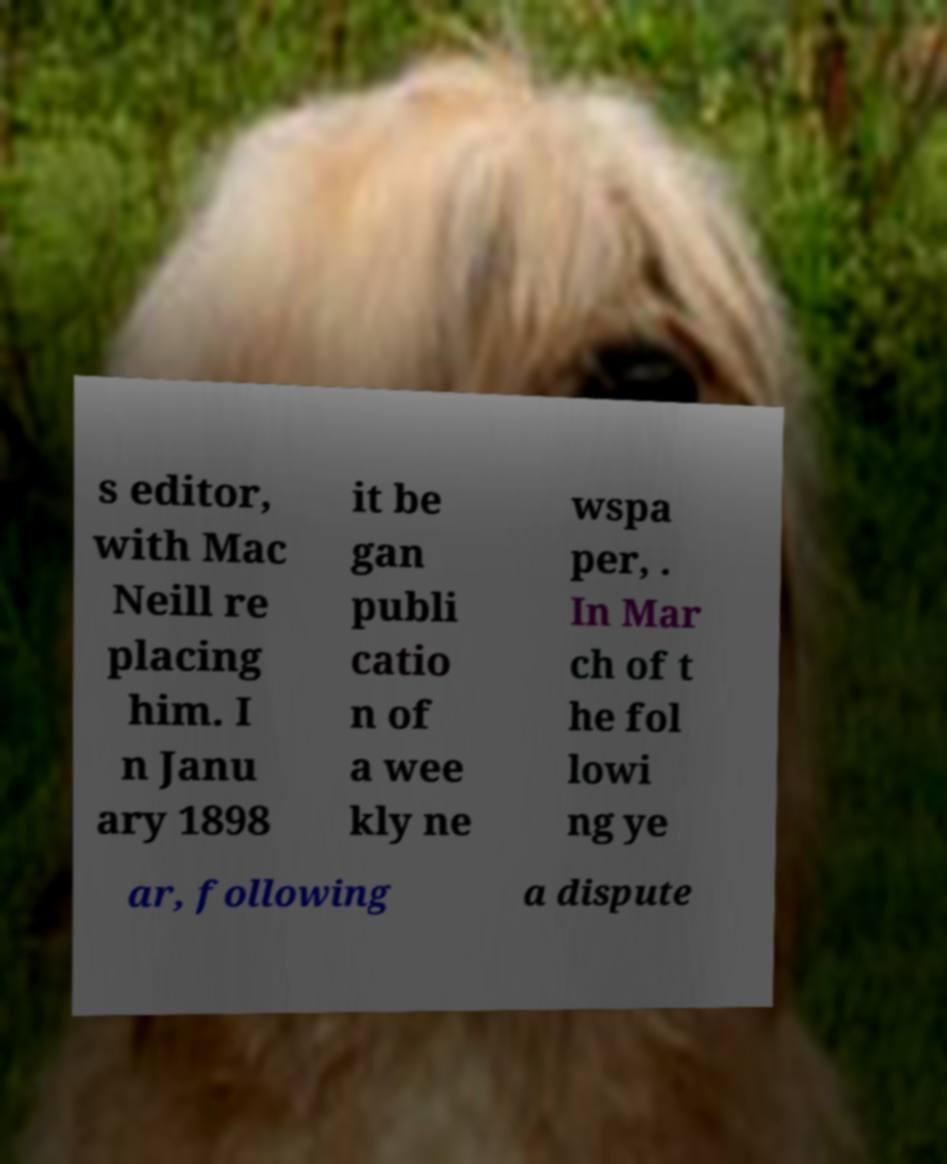Could you assist in decoding the text presented in this image and type it out clearly? s editor, with Mac Neill re placing him. I n Janu ary 1898 it be gan publi catio n of a wee kly ne wspa per, . In Mar ch of t he fol lowi ng ye ar, following a dispute 